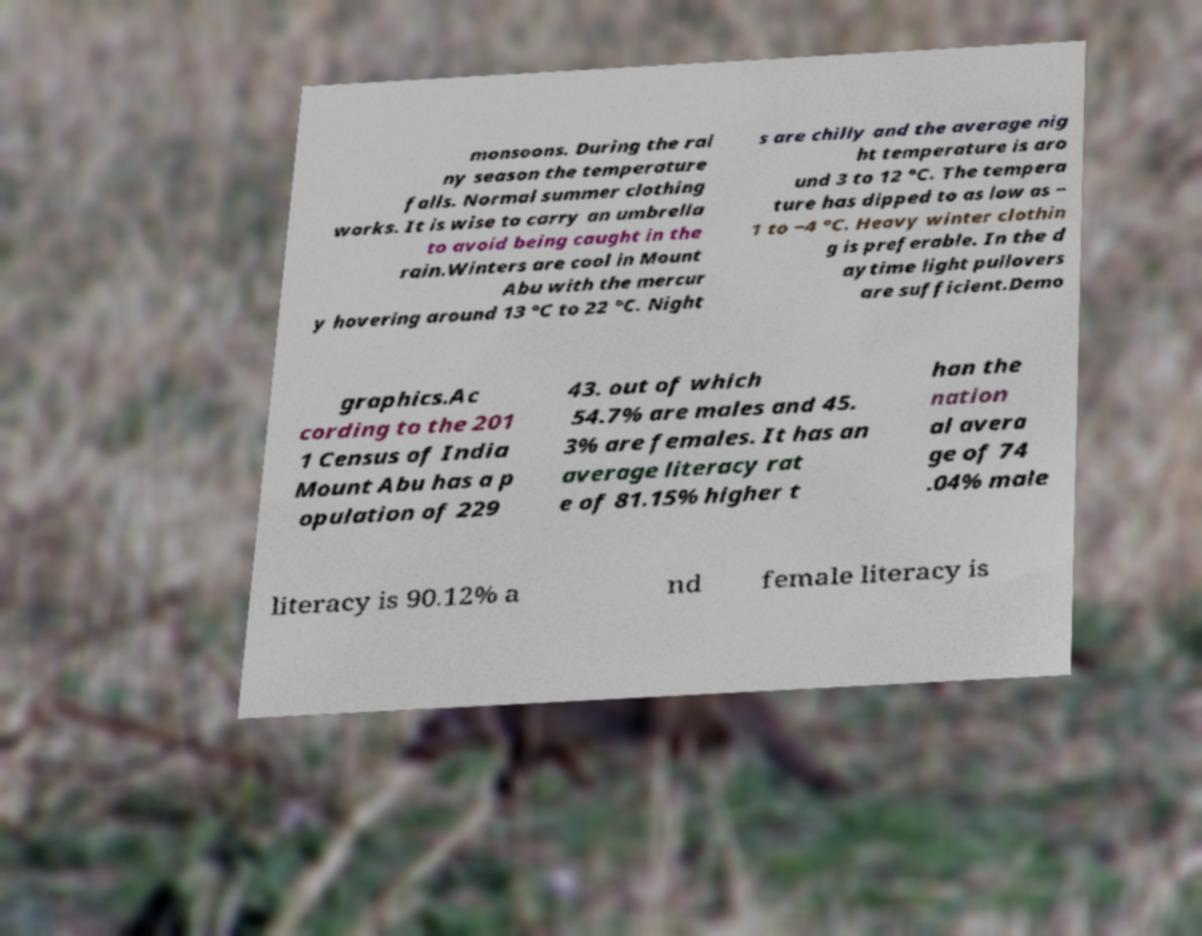Can you read and provide the text displayed in the image?This photo seems to have some interesting text. Can you extract and type it out for me? monsoons. During the rai ny season the temperature falls. Normal summer clothing works. It is wise to carry an umbrella to avoid being caught in the rain.Winters are cool in Mount Abu with the mercur y hovering around 13 °C to 22 °C. Night s are chilly and the average nig ht temperature is aro und 3 to 12 °C. The tempera ture has dipped to as low as − 1 to −4 °C. Heavy winter clothin g is preferable. In the d aytime light pullovers are sufficient.Demo graphics.Ac cording to the 201 1 Census of India Mount Abu has a p opulation of 229 43. out of which 54.7% are males and 45. 3% are females. It has an average literacy rat e of 81.15% higher t han the nation al avera ge of 74 .04% male literacy is 90.12% a nd female literacy is 